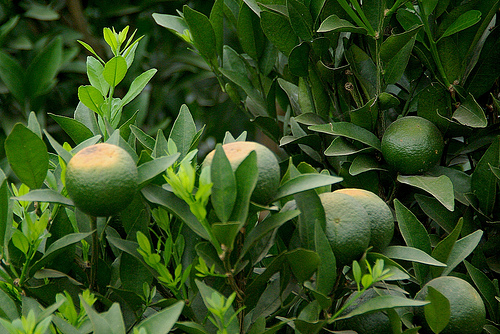<image>
Is there a lemon behind the rock? No. The lemon is not behind the rock. From this viewpoint, the lemon appears to be positioned elsewhere in the scene. 